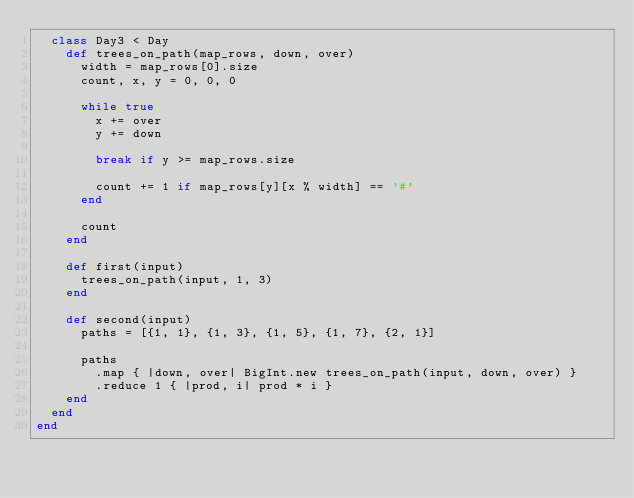Convert code to text. <code><loc_0><loc_0><loc_500><loc_500><_Crystal_>  class Day3 < Day
    def trees_on_path(map_rows, down, over)
      width = map_rows[0].size
      count, x, y = 0, 0, 0

      while true
        x += over
        y += down

        break if y >= map_rows.size

        count += 1 if map_rows[y][x % width] == '#'
      end

      count
    end

    def first(input)
      trees_on_path(input, 1, 3)
    end

    def second(input)
      paths = [{1, 1}, {1, 3}, {1, 5}, {1, 7}, {2, 1}]

      paths
        .map { |down, over| BigInt.new trees_on_path(input, down, over) }
        .reduce 1 { |prod, i| prod * i }
    end
  end
end
</code> 